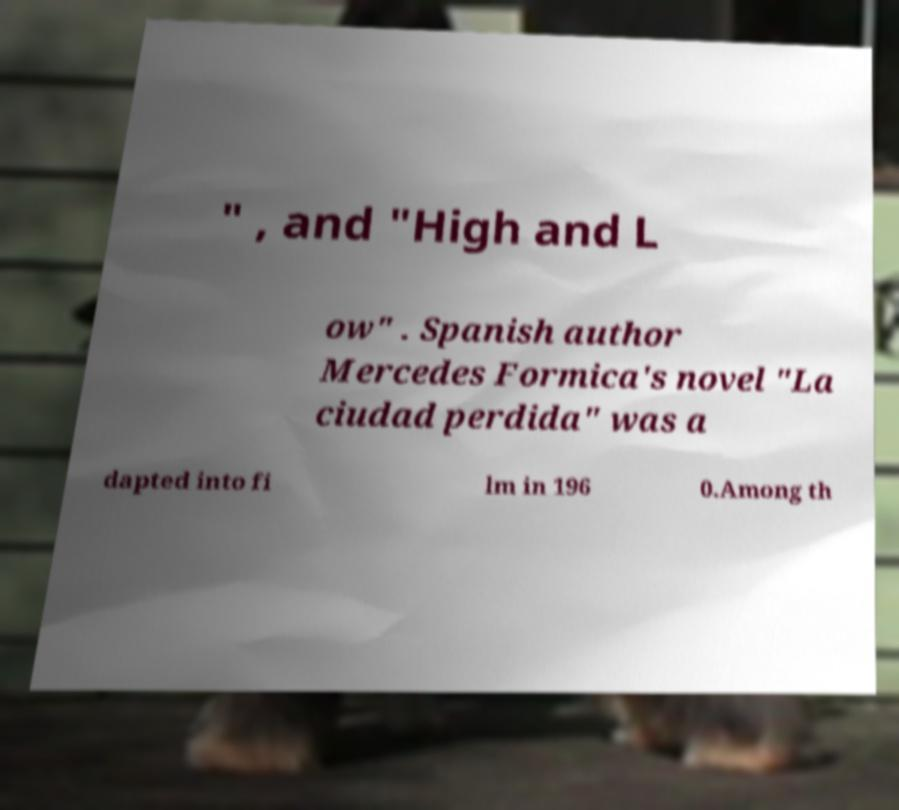Please read and relay the text visible in this image. What does it say? " , and "High and L ow" . Spanish author Mercedes Formica's novel "La ciudad perdida" was a dapted into fi lm in 196 0.Among th 